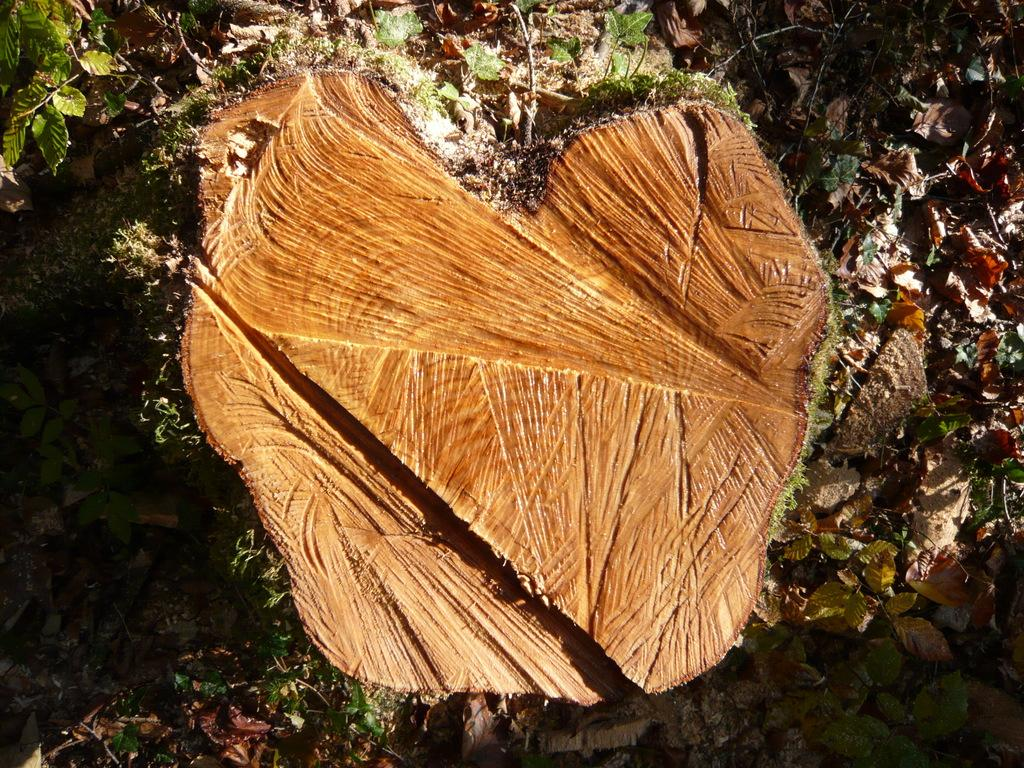What is the main subject of the image? The main subject of the image is a tree trunk. What is the color of the tree trunk? The tree trunk is brown in color. What else can be seen on the ground in the image? There are dried leaves on the land in the image. What is the color of the dried leaves? The dried leaves are brown in color. color. What type of art is being created with the tree trunk and dried leaves in the image? There is no indication of any art being created in the image; it simply shows a tree trunk and dried leaves on the ground. What is the current status of the tree trunk in the image? The tree trunk is a stationary object in the image, and there is no information about its current status. 